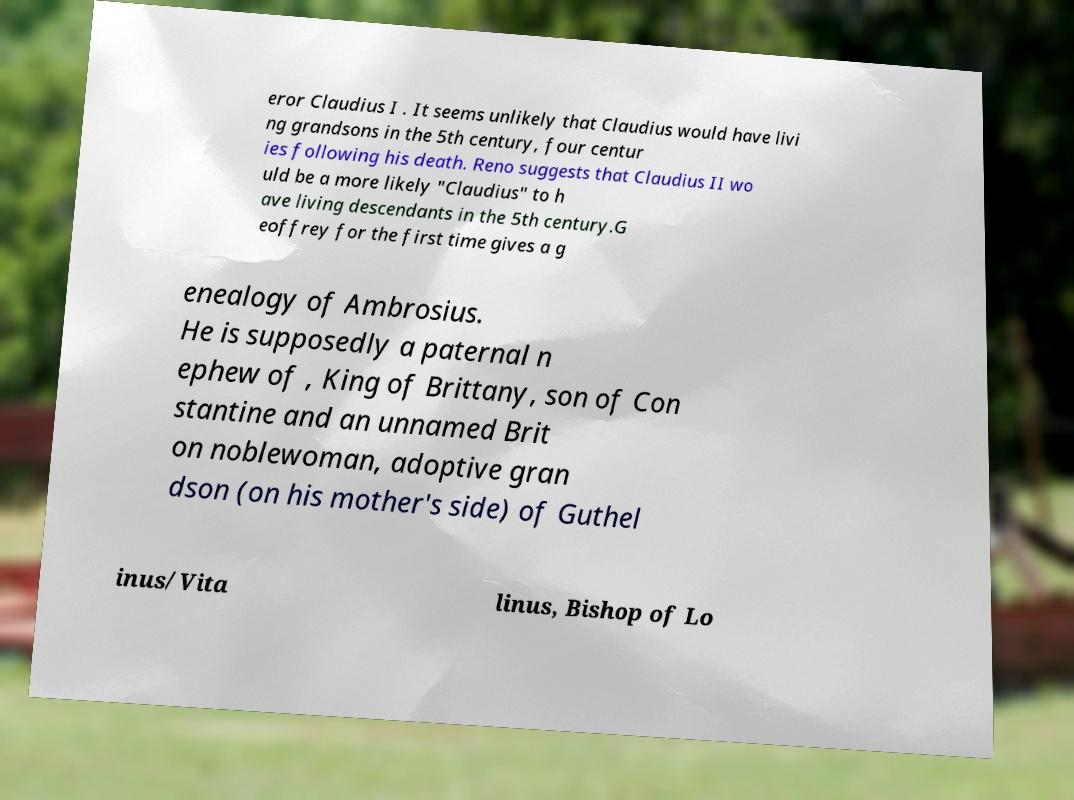Can you accurately transcribe the text from the provided image for me? eror Claudius I . It seems unlikely that Claudius would have livi ng grandsons in the 5th century, four centur ies following his death. Reno suggests that Claudius II wo uld be a more likely "Claudius" to h ave living descendants in the 5th century.G eoffrey for the first time gives a g enealogy of Ambrosius. He is supposedly a paternal n ephew of , King of Brittany, son of Con stantine and an unnamed Brit on noblewoman, adoptive gran dson (on his mother's side) of Guthel inus/Vita linus, Bishop of Lo 